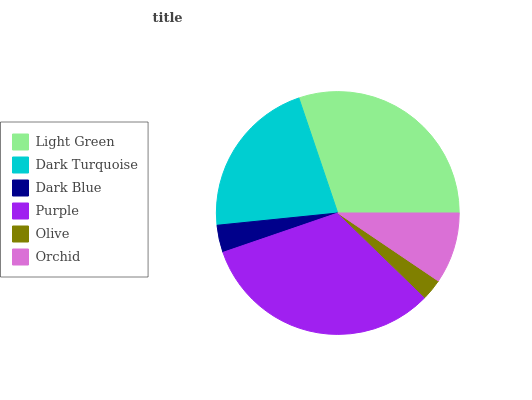Is Olive the minimum?
Answer yes or no. Yes. Is Purple the maximum?
Answer yes or no. Yes. Is Dark Turquoise the minimum?
Answer yes or no. No. Is Dark Turquoise the maximum?
Answer yes or no. No. Is Light Green greater than Dark Turquoise?
Answer yes or no. Yes. Is Dark Turquoise less than Light Green?
Answer yes or no. Yes. Is Dark Turquoise greater than Light Green?
Answer yes or no. No. Is Light Green less than Dark Turquoise?
Answer yes or no. No. Is Dark Turquoise the high median?
Answer yes or no. Yes. Is Orchid the low median?
Answer yes or no. Yes. Is Orchid the high median?
Answer yes or no. No. Is Dark Turquoise the low median?
Answer yes or no. No. 